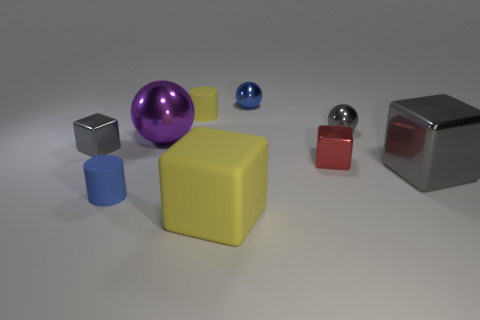Subtract 1 cubes. How many cubes are left? 3 Subtract all blocks. How many objects are left? 5 Subtract 1 purple balls. How many objects are left? 8 Subtract all tiny shiny balls. Subtract all small balls. How many objects are left? 5 Add 5 small yellow objects. How many small yellow objects are left? 6 Add 5 brown shiny spheres. How many brown shiny spheres exist? 5 